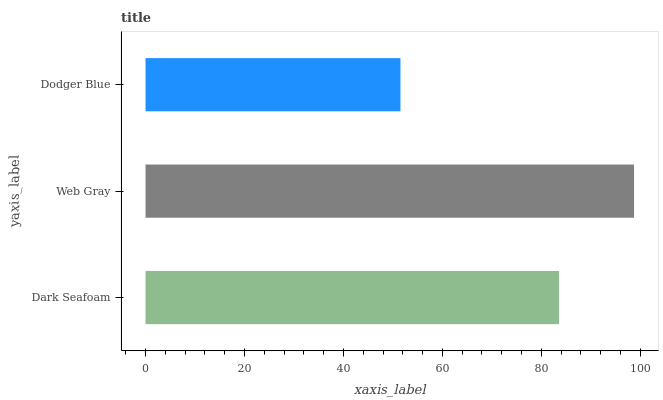Is Dodger Blue the minimum?
Answer yes or no. Yes. Is Web Gray the maximum?
Answer yes or no. Yes. Is Web Gray the minimum?
Answer yes or no. No. Is Dodger Blue the maximum?
Answer yes or no. No. Is Web Gray greater than Dodger Blue?
Answer yes or no. Yes. Is Dodger Blue less than Web Gray?
Answer yes or no. Yes. Is Dodger Blue greater than Web Gray?
Answer yes or no. No. Is Web Gray less than Dodger Blue?
Answer yes or no. No. Is Dark Seafoam the high median?
Answer yes or no. Yes. Is Dark Seafoam the low median?
Answer yes or no. Yes. Is Web Gray the high median?
Answer yes or no. No. Is Web Gray the low median?
Answer yes or no. No. 